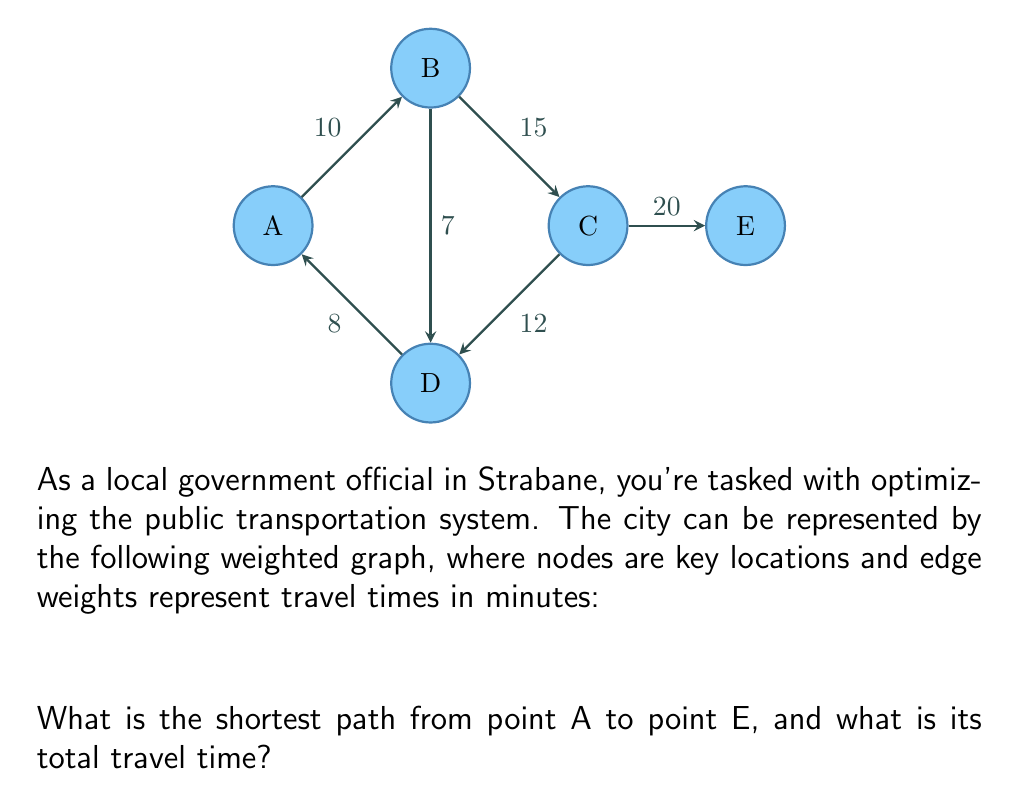What is the answer to this math problem? A → D → C → E, 40 minutes 